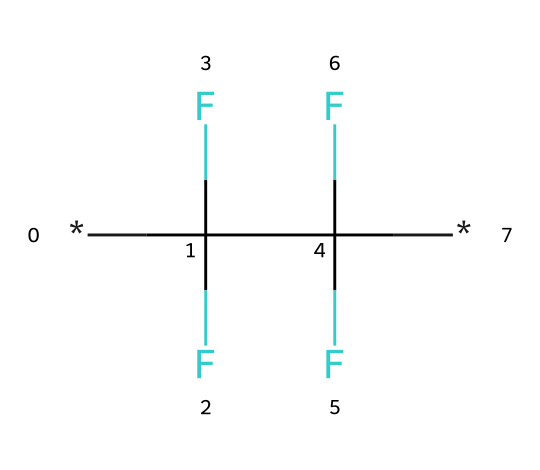What is the name of this chemical? The SMILES representation shows multiple carbon and fluorine atoms, which corresponds to polytetrafluoroethylene, widely known as Teflon.
Answer: polytetrafluoroethylene How many carbon atoms are in this molecule? From the SMILES representation, we can count the carbon atoms, which are indicated by the letter "C." There are two carbon atoms in the structure.
Answer: 2 What type of plastic is represented by this chemical? This chemical, with its highly fluorinated structure, is classified as a fluoropolymer, which is a specific type of plastic known for its non-reactivity.
Answer: fluoropolymer How many fluorine atoms are present? The SMILES code indicates that there are four fluorine atoms associated with each carbon, resulting in a total of four fluorine atoms in the structure (2 carbons x 2 fluorines each).
Answer: 4 What is a primary property of this chemical? The highly fluorinated nature of this molecule gives it exceptional non-reactivity, making it ideal for lab containers where chemical resistance is critical.
Answer: non-reactive What allows this chemical to withstand high temperatures? The strong carbon-fluorine bonds in the polymer structure contribute to its thermal stability, allowing it to maintain integrity and resist degradation at high temperatures.
Answer: strong bonds What is the structural characteristic that contributes to its chemical inertness? The absence of hydrogen atoms and the presence of strong carbon-fluorine bonds create a stable structure that resists chemical reactions, leading to high inertness.
Answer: absence of hydrogen 